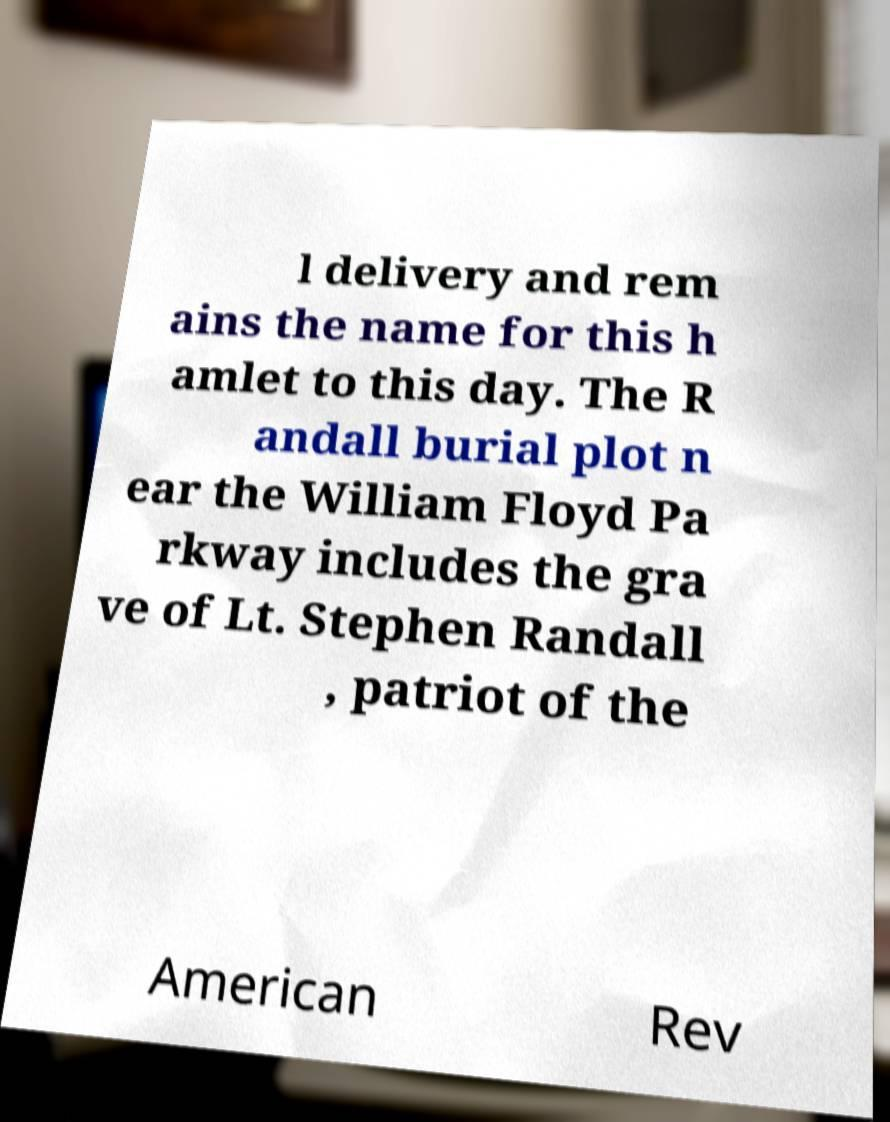Can you accurately transcribe the text from the provided image for me? l delivery and rem ains the name for this h amlet to this day. The R andall burial plot n ear the William Floyd Pa rkway includes the gra ve of Lt. Stephen Randall , patriot of the American Rev 